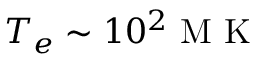<formula> <loc_0><loc_0><loc_500><loc_500>T _ { e } \sim 1 0 ^ { 2 } M K</formula> 